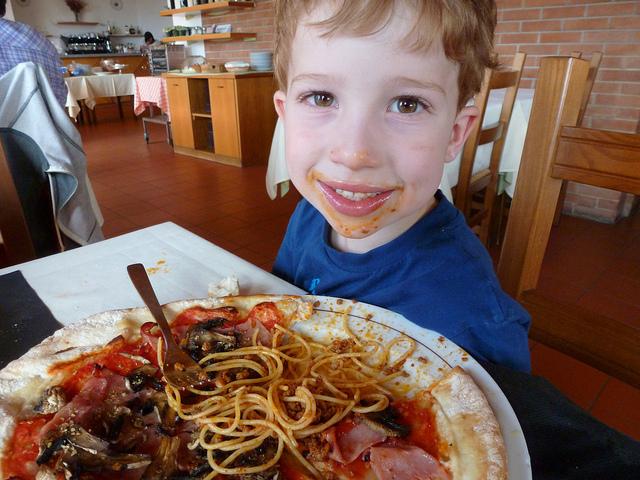Is there a fork in the picture?
Write a very short answer. Yes. Is this child sad?
Answer briefly. No. Is he wearing a bib?
Answer briefly. No. 